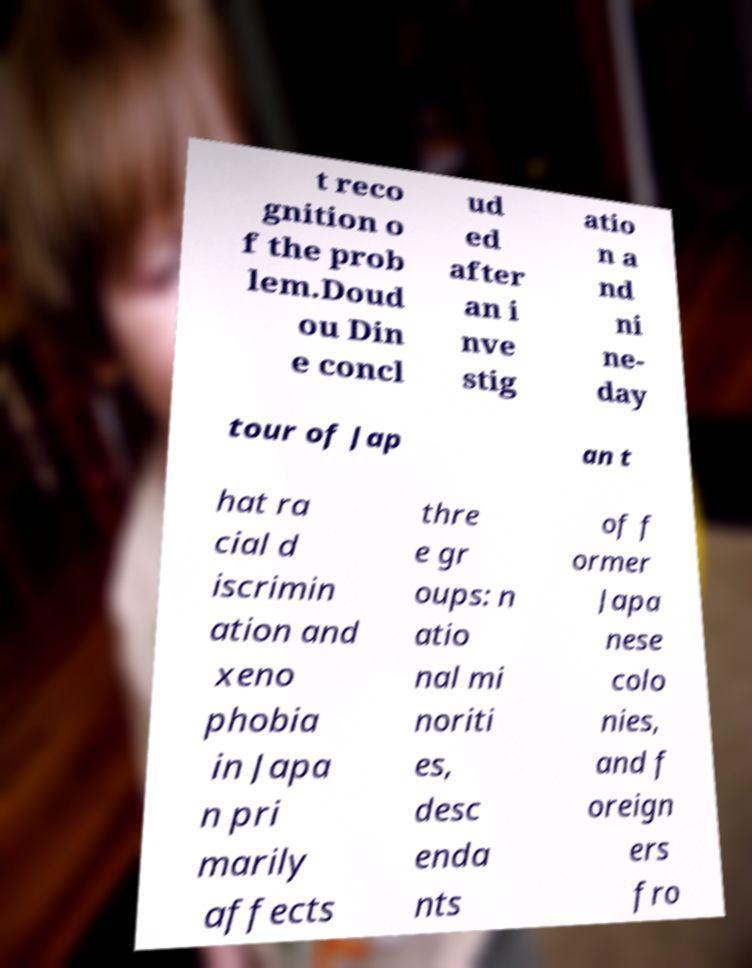Can you accurately transcribe the text from the provided image for me? t reco gnition o f the prob lem.Doud ou Din e concl ud ed after an i nve stig atio n a nd ni ne- day tour of Jap an t hat ra cial d iscrimin ation and xeno phobia in Japa n pri marily affects thre e gr oups: n atio nal mi noriti es, desc enda nts of f ormer Japa nese colo nies, and f oreign ers fro 